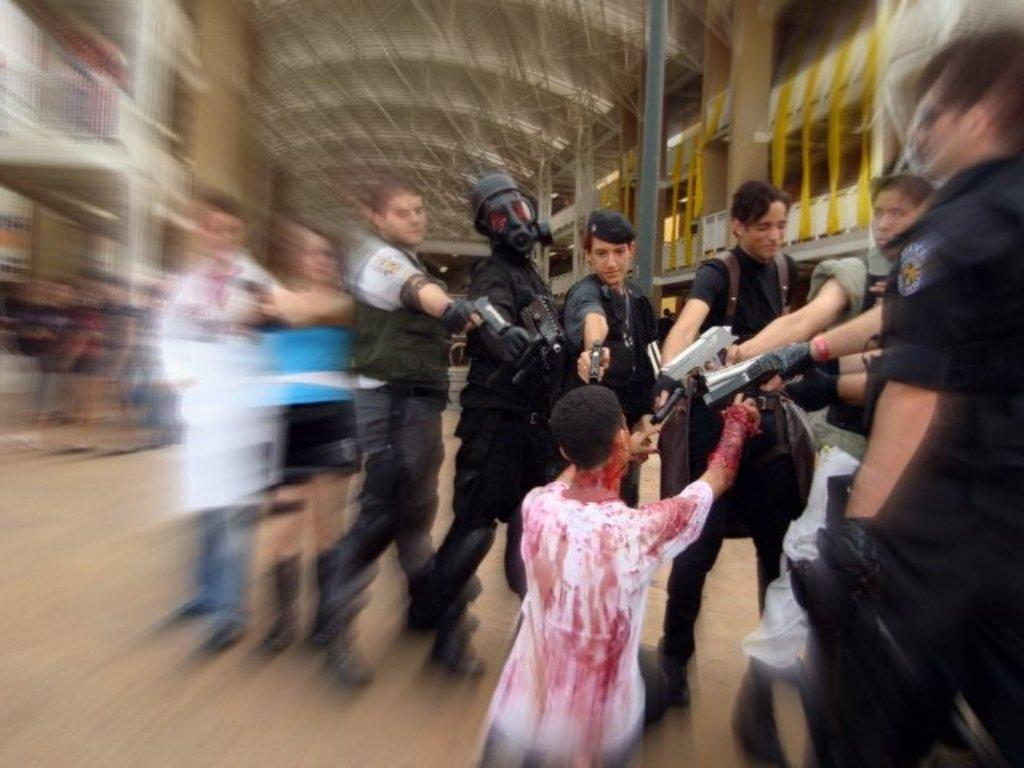What are the persons in the image doing? The persons in the image are standing on the floor and holding guns in their hands. What can be seen in the background of the image? There are buildings in the background of the image. Can you see any fog or mist in the image? There is no mention of fog or mist in the image; it only shows persons holding guns and buildings in the background. 